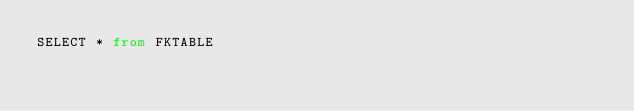<code> <loc_0><loc_0><loc_500><loc_500><_SQL_>SELECT * from FKTABLE
</code> 